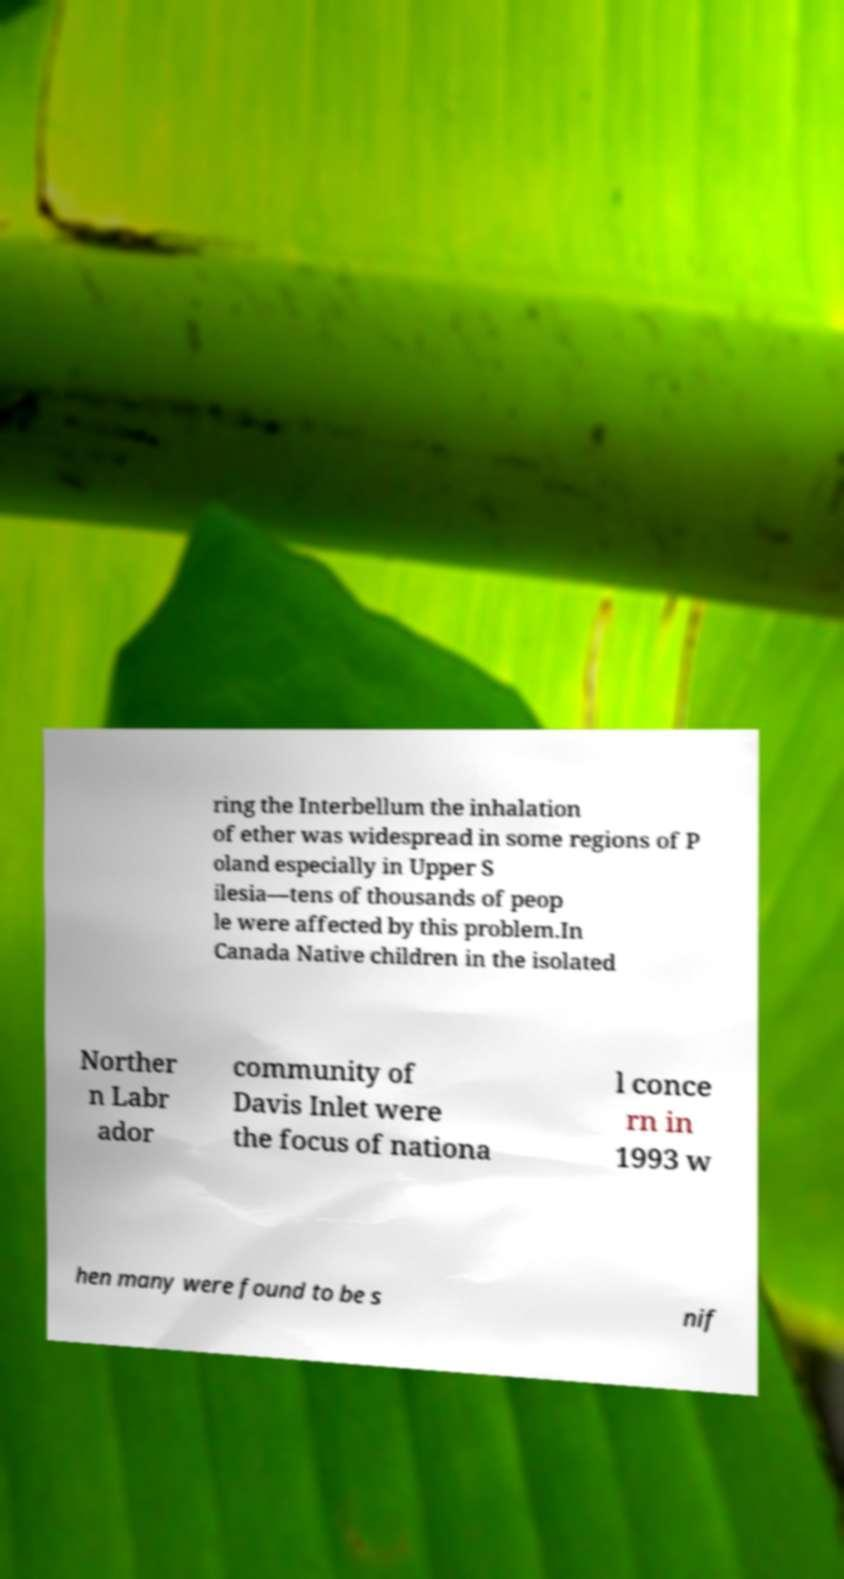Could you assist in decoding the text presented in this image and type it out clearly? ring the Interbellum the inhalation of ether was widespread in some regions of P oland especially in Upper S ilesia—tens of thousands of peop le were affected by this problem.In Canada Native children in the isolated Norther n Labr ador community of Davis Inlet were the focus of nationa l conce rn in 1993 w hen many were found to be s nif 